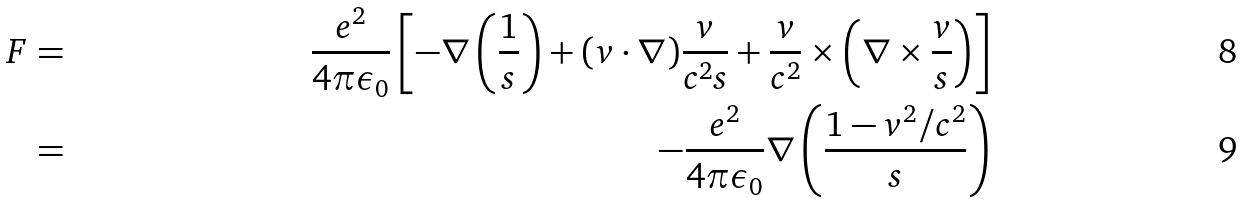Convert formula to latex. <formula><loc_0><loc_0><loc_500><loc_500>F & = & \frac { e ^ { 2 } } { 4 \pi \epsilon _ { 0 } } \left [ - \nabla \left ( \frac { 1 } { s } \right ) + ( v \cdot \nabla ) \frac { v } { c ^ { 2 } s } + \frac { v } { c ^ { 2 } } \times \left ( \nabla \times \frac { v } { s } \right ) \right ] \\ & = & - \frac { e ^ { 2 } } { 4 \pi \epsilon _ { 0 } } \nabla \left ( \frac { 1 - v ^ { 2 } / c ^ { 2 } } { s } \right )</formula> 